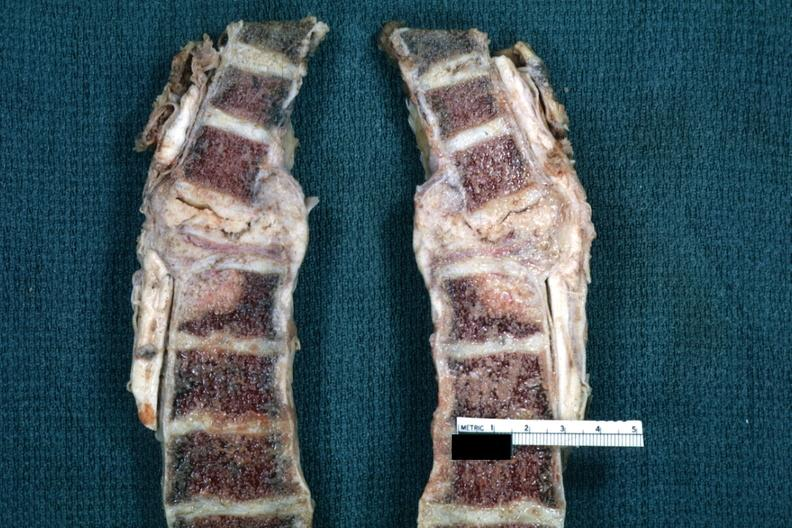what does this image show?
Answer the question using a single word or phrase. Fixed tissue saggital section spine with replacement of t4 by tumor and with collapse primary lesion squamous cell carcinoma of esophagus 